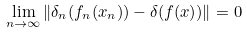<formula> <loc_0><loc_0><loc_500><loc_500>\lim _ { n \to \infty } \| \delta _ { n } ( f _ { n } ( x _ { n } ) ) - \delta ( f ( x ) ) \| = 0</formula> 